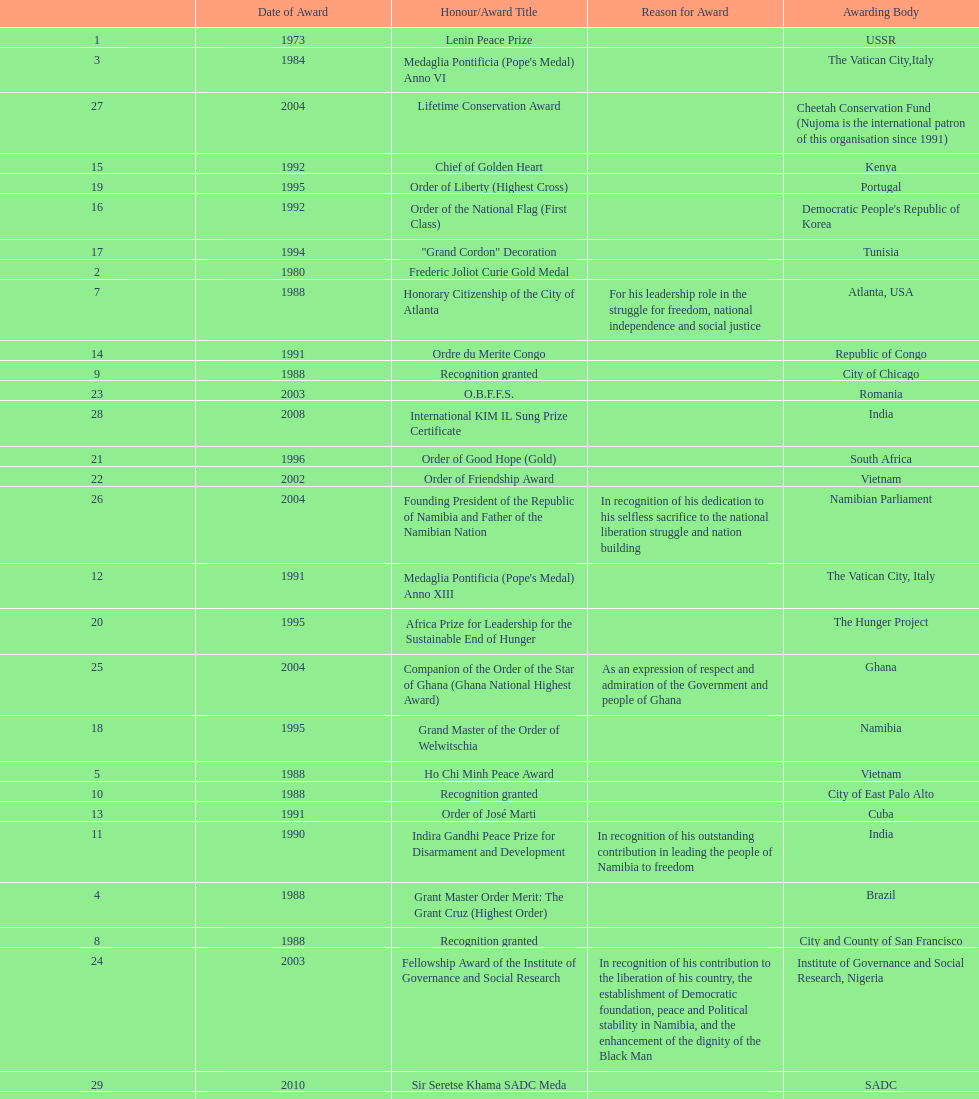The "fellowship award of the institute of governance and social research" was awarded in 2003 or 2004? 2003. 